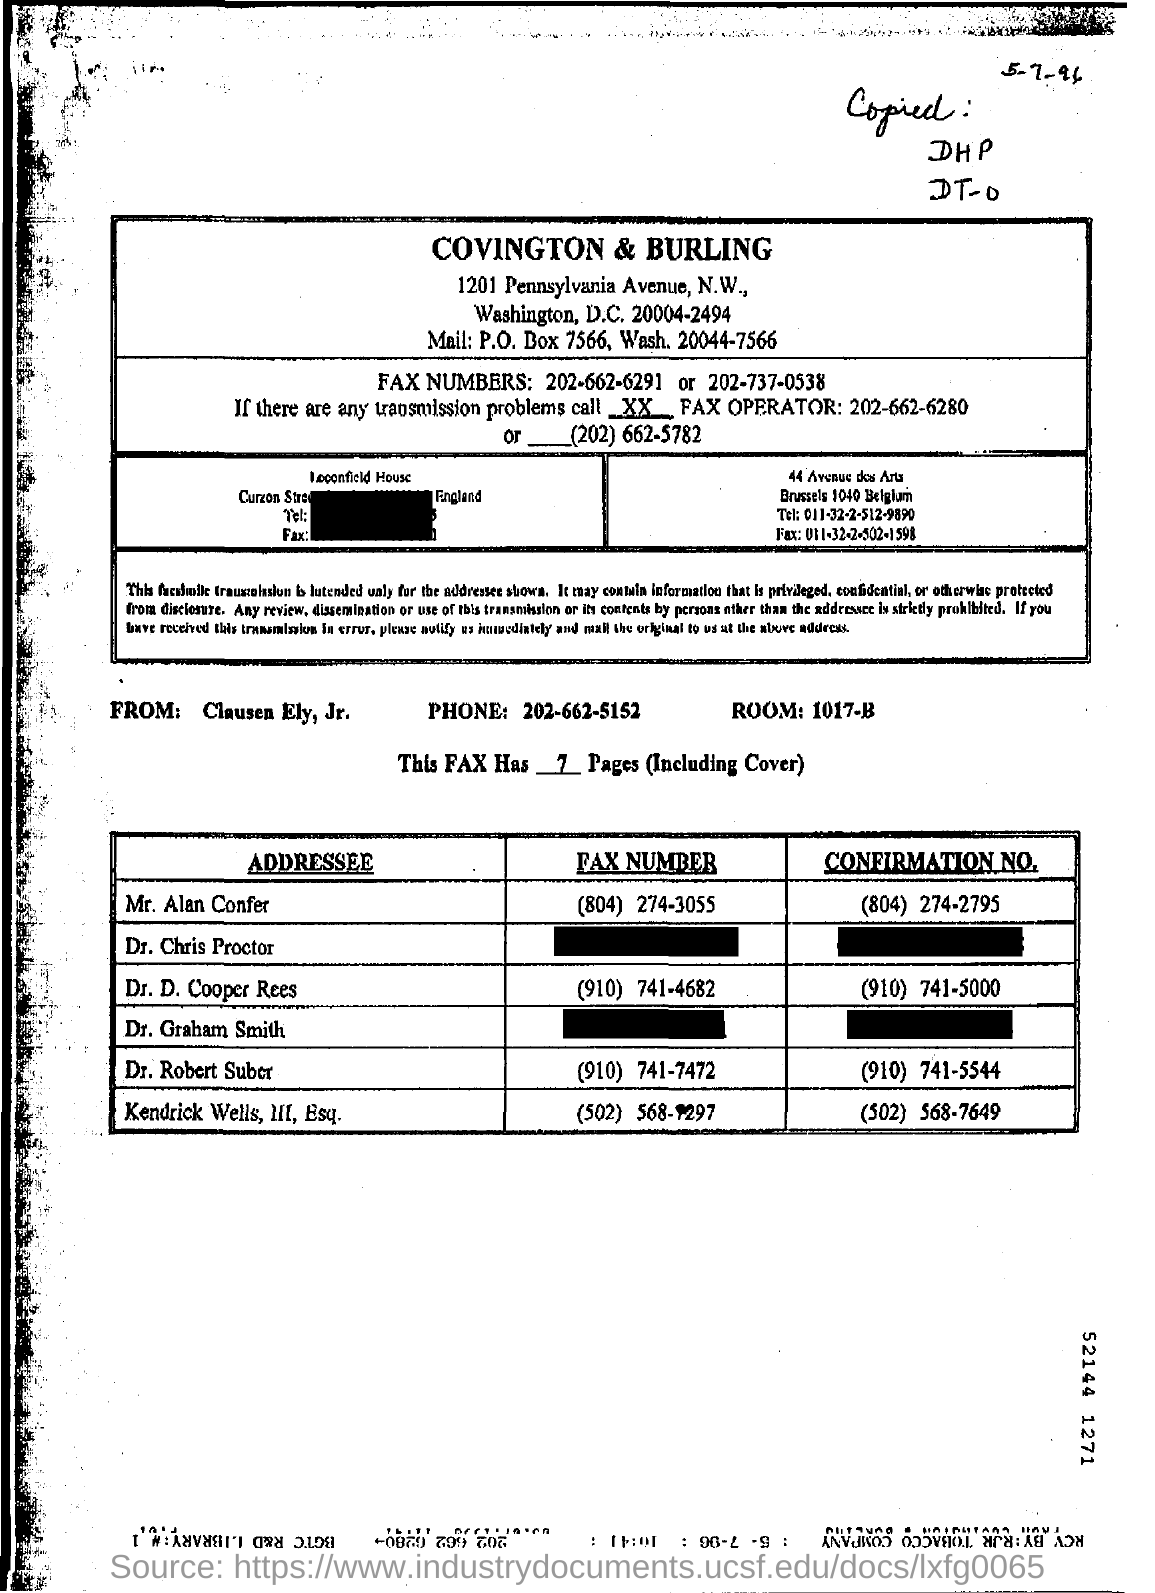Who is the sender of the FAX?
Ensure brevity in your answer.  Clausen Ely, Jr. What is the Phone no of Clausen Ely, Jr. ?
Offer a very short reply. 202-662-5152. What is the Confirmation No. given for Dr. D. Cooper Rees ?
Provide a short and direct response. (910) 741-5000. What is the Fax No of Mr. Alan Confer?
Offer a very short reply. (804) 274-3055. 